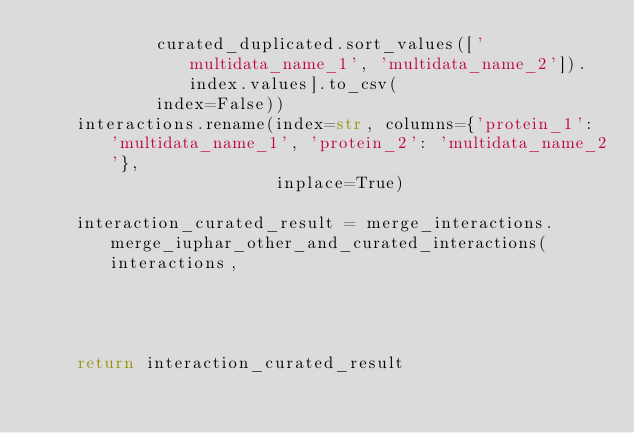<code> <loc_0><loc_0><loc_500><loc_500><_Python_>            curated_duplicated.sort_values(['multidata_name_1', 'multidata_name_2']).index.values].to_csv(
            index=False))
    interactions.rename(index=str, columns={'protein_1': 'multidata_name_1', 'protein_2': 'multidata_name_2'},
                        inplace=True)

    interaction_curated_result = merge_interactions.merge_iuphar_other_and_curated_interactions(interactions,
                                                                                                interaction_curated)

    return interaction_curated_result
</code> 